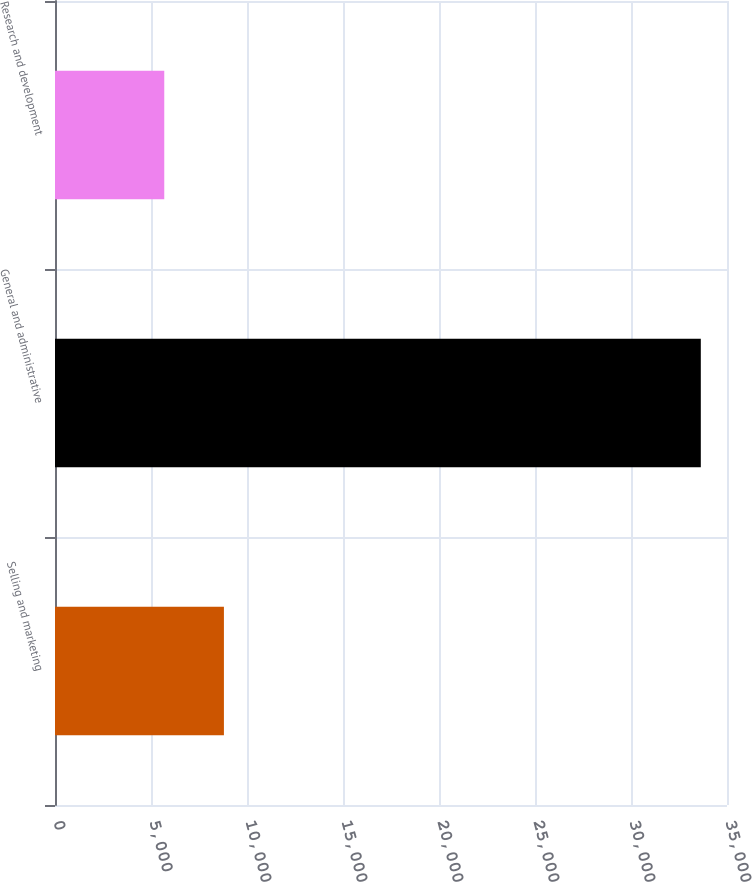Convert chart. <chart><loc_0><loc_0><loc_500><loc_500><bar_chart><fcel>Selling and marketing<fcel>General and administrative<fcel>Research and development<nl><fcel>8798<fcel>33636<fcel>5691<nl></chart> 